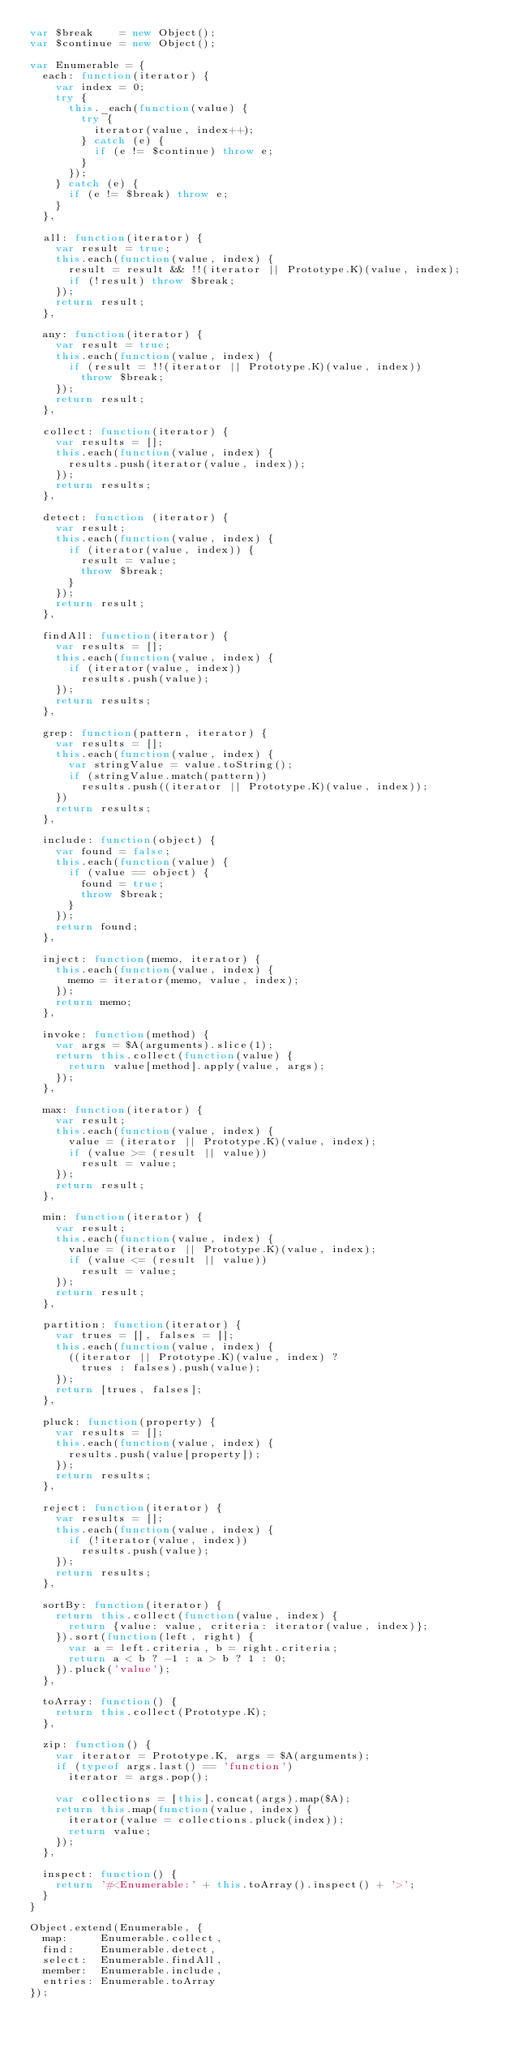Convert code to text. <code><loc_0><loc_0><loc_500><loc_500><_JavaScript_>var $break    = new Object();
var $continue = new Object();

var Enumerable = {
  each: function(iterator) {
    var index = 0;
    try {
      this._each(function(value) {
        try {
          iterator(value, index++);
        } catch (e) {
          if (e != $continue) throw e;
        }
      });
    } catch (e) {
      if (e != $break) throw e;
    }
  },
  
  all: function(iterator) {
    var result = true;
    this.each(function(value, index) {
      result = result && !!(iterator || Prototype.K)(value, index);
      if (!result) throw $break;
    });
    return result;
  },
  
  any: function(iterator) {
    var result = true;
    this.each(function(value, index) {
      if (result = !!(iterator || Prototype.K)(value, index)) 
        throw $break;
    });
    return result;
  },
  
  collect: function(iterator) {
    var results = [];
    this.each(function(value, index) {
      results.push(iterator(value, index));
    });
    return results;
  },
  
  detect: function (iterator) {
    var result;
    this.each(function(value, index) {
      if (iterator(value, index)) {
        result = value;
        throw $break;
      }
    });
    return result;
  },
  
  findAll: function(iterator) {
    var results = [];
    this.each(function(value, index) {
      if (iterator(value, index))
        results.push(value);
    });
    return results;
  },
  
  grep: function(pattern, iterator) {
    var results = [];
    this.each(function(value, index) {
      var stringValue = value.toString();
      if (stringValue.match(pattern))
        results.push((iterator || Prototype.K)(value, index));
    })
    return results;
  },
  
  include: function(object) {
    var found = false;
    this.each(function(value) {
      if (value == object) {
        found = true;
        throw $break;
      }
    });
    return found;
  },
  
  inject: function(memo, iterator) {
    this.each(function(value, index) {
      memo = iterator(memo, value, index);
    });
    return memo;
  },
  
  invoke: function(method) {
    var args = $A(arguments).slice(1);
    return this.collect(function(value) {
      return value[method].apply(value, args);
    });
  },
  
  max: function(iterator) {
    var result;
    this.each(function(value, index) {
      value = (iterator || Prototype.K)(value, index);
      if (value >= (result || value))
        result = value;
    });
    return result;
  },
  
  min: function(iterator) {
    var result;
    this.each(function(value, index) {
      value = (iterator || Prototype.K)(value, index);
      if (value <= (result || value))
        result = value;
    });
    return result;
  },
  
  partition: function(iterator) {
    var trues = [], falses = [];
    this.each(function(value, index) {
      ((iterator || Prototype.K)(value, index) ? 
        trues : falses).push(value);
    });
    return [trues, falses];
  },
  
  pluck: function(property) {
    var results = [];
    this.each(function(value, index) {
      results.push(value[property]);
    });
    return results;
  },
  
  reject: function(iterator) {
    var results = [];
    this.each(function(value, index) {
      if (!iterator(value, index))
        results.push(value);
    });
    return results;
  },
  
  sortBy: function(iterator) {
    return this.collect(function(value, index) {
      return {value: value, criteria: iterator(value, index)};
    }).sort(function(left, right) {
      var a = left.criteria, b = right.criteria;
      return a < b ? -1 : a > b ? 1 : 0;
    }).pluck('value');
  },
  
  toArray: function() {
    return this.collect(Prototype.K);
  },
  
  zip: function() {
    var iterator = Prototype.K, args = $A(arguments);
    if (typeof args.last() == 'function')
      iterator = args.pop();

    var collections = [this].concat(args).map($A);
    return this.map(function(value, index) {
      iterator(value = collections.pluck(index));
      return value;
    });
  },
  
  inspect: function() {
    return '#<Enumerable:' + this.toArray().inspect() + '>';
  }
}

Object.extend(Enumerable, {
  map:     Enumerable.collect,
  find:    Enumerable.detect,
  select:  Enumerable.findAll,
  member:  Enumerable.include,
  entries: Enumerable.toArray
});
</code> 